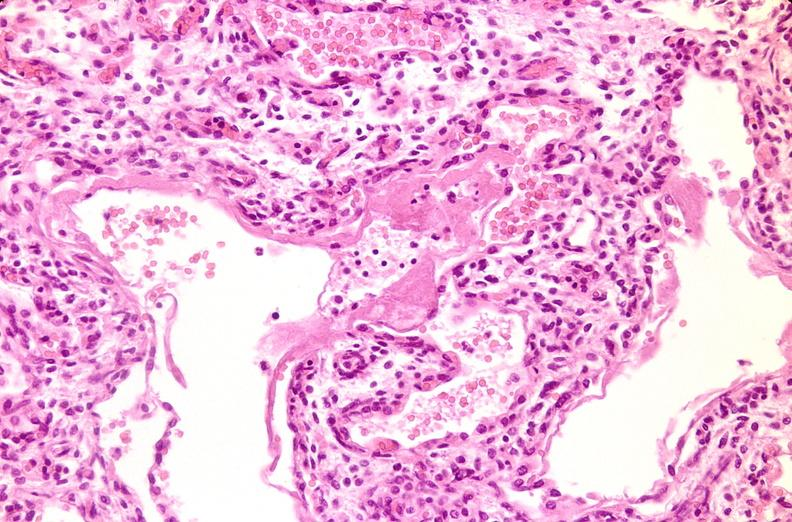s respiratory present?
Answer the question using a single word or phrase. Yes 